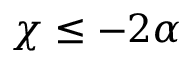<formula> <loc_0><loc_0><loc_500><loc_500>\chi \leq - 2 \alpha</formula> 